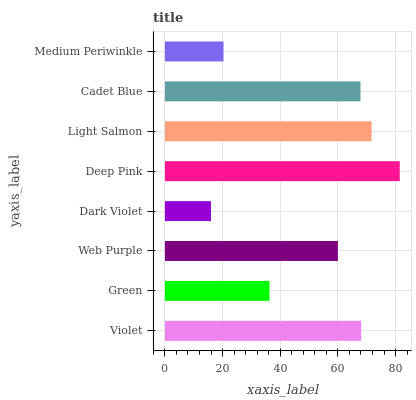Is Dark Violet the minimum?
Answer yes or no. Yes. Is Deep Pink the maximum?
Answer yes or no. Yes. Is Green the minimum?
Answer yes or no. No. Is Green the maximum?
Answer yes or no. No. Is Violet greater than Green?
Answer yes or no. Yes. Is Green less than Violet?
Answer yes or no. Yes. Is Green greater than Violet?
Answer yes or no. No. Is Violet less than Green?
Answer yes or no. No. Is Cadet Blue the high median?
Answer yes or no. Yes. Is Web Purple the low median?
Answer yes or no. Yes. Is Medium Periwinkle the high median?
Answer yes or no. No. Is Cadet Blue the low median?
Answer yes or no. No. 